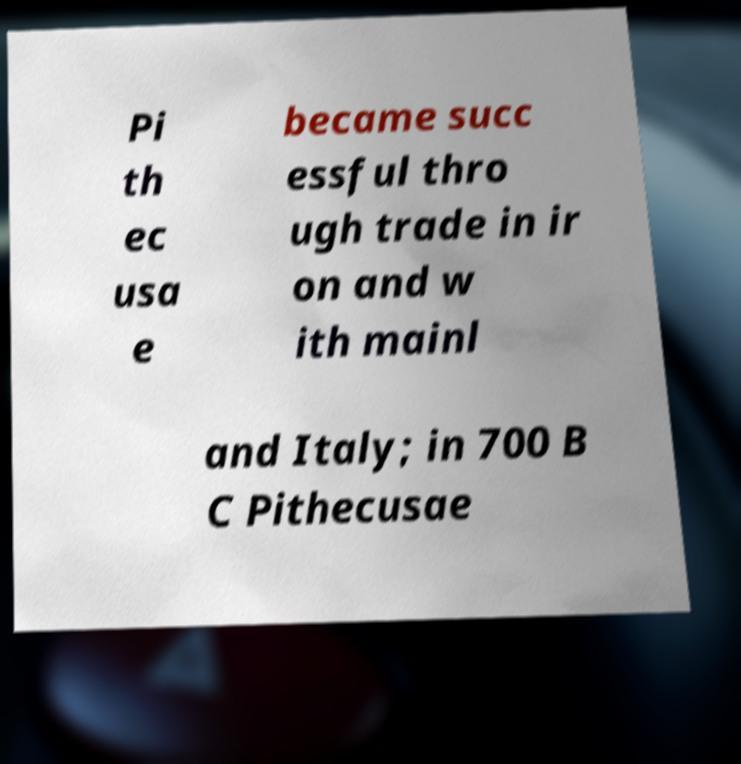I need the written content from this picture converted into text. Can you do that? Pi th ec usa e became succ essful thro ugh trade in ir on and w ith mainl and Italy; in 700 B C Pithecusae 